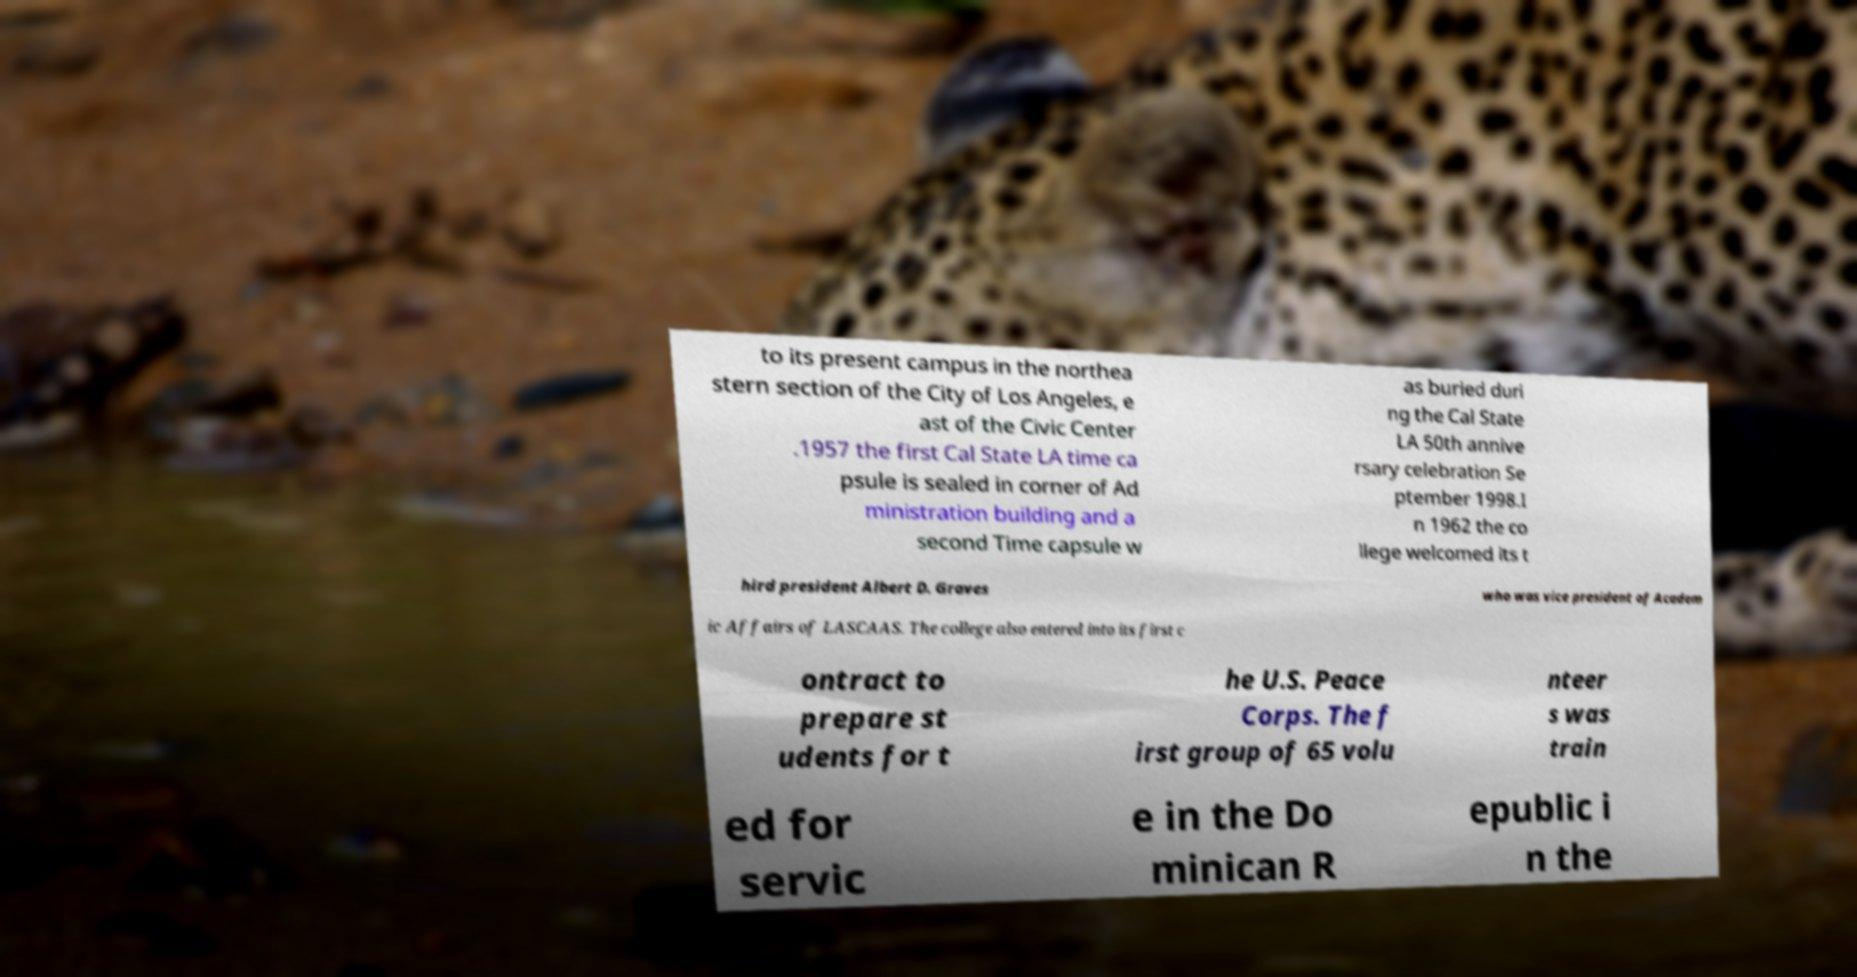What messages or text are displayed in this image? I need them in a readable, typed format. to its present campus in the northea stern section of the City of Los Angeles, e ast of the Civic Center .1957 the first Cal State LA time ca psule is sealed in corner of Ad ministration building and a second Time capsule w as buried duri ng the Cal State LA 50th annive rsary celebration Se ptember 1998.I n 1962 the co llege welcomed its t hird president Albert D. Graves who was vice president of Academ ic Affairs of LASCAAS. The college also entered into its first c ontract to prepare st udents for t he U.S. Peace Corps. The f irst group of 65 volu nteer s was train ed for servic e in the Do minican R epublic i n the 